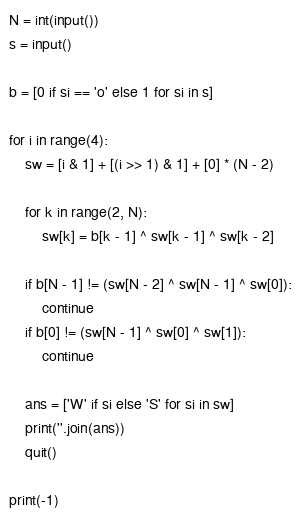Convert code to text. <code><loc_0><loc_0><loc_500><loc_500><_Python_>N = int(input())
s = input()

b = [0 if si == 'o' else 1 for si in s]

for i in range(4):
    sw = [i & 1] + [(i >> 1) & 1] + [0] * (N - 2)

    for k in range(2, N):
        sw[k] = b[k - 1] ^ sw[k - 1] ^ sw[k - 2]

    if b[N - 1] != (sw[N - 2] ^ sw[N - 1] ^ sw[0]):
        continue
    if b[0] != (sw[N - 1] ^ sw[0] ^ sw[1]):
        continue

    ans = ['W' if si else 'S' for si in sw]
    print(''.join(ans))
    quit()

print(-1)</code> 